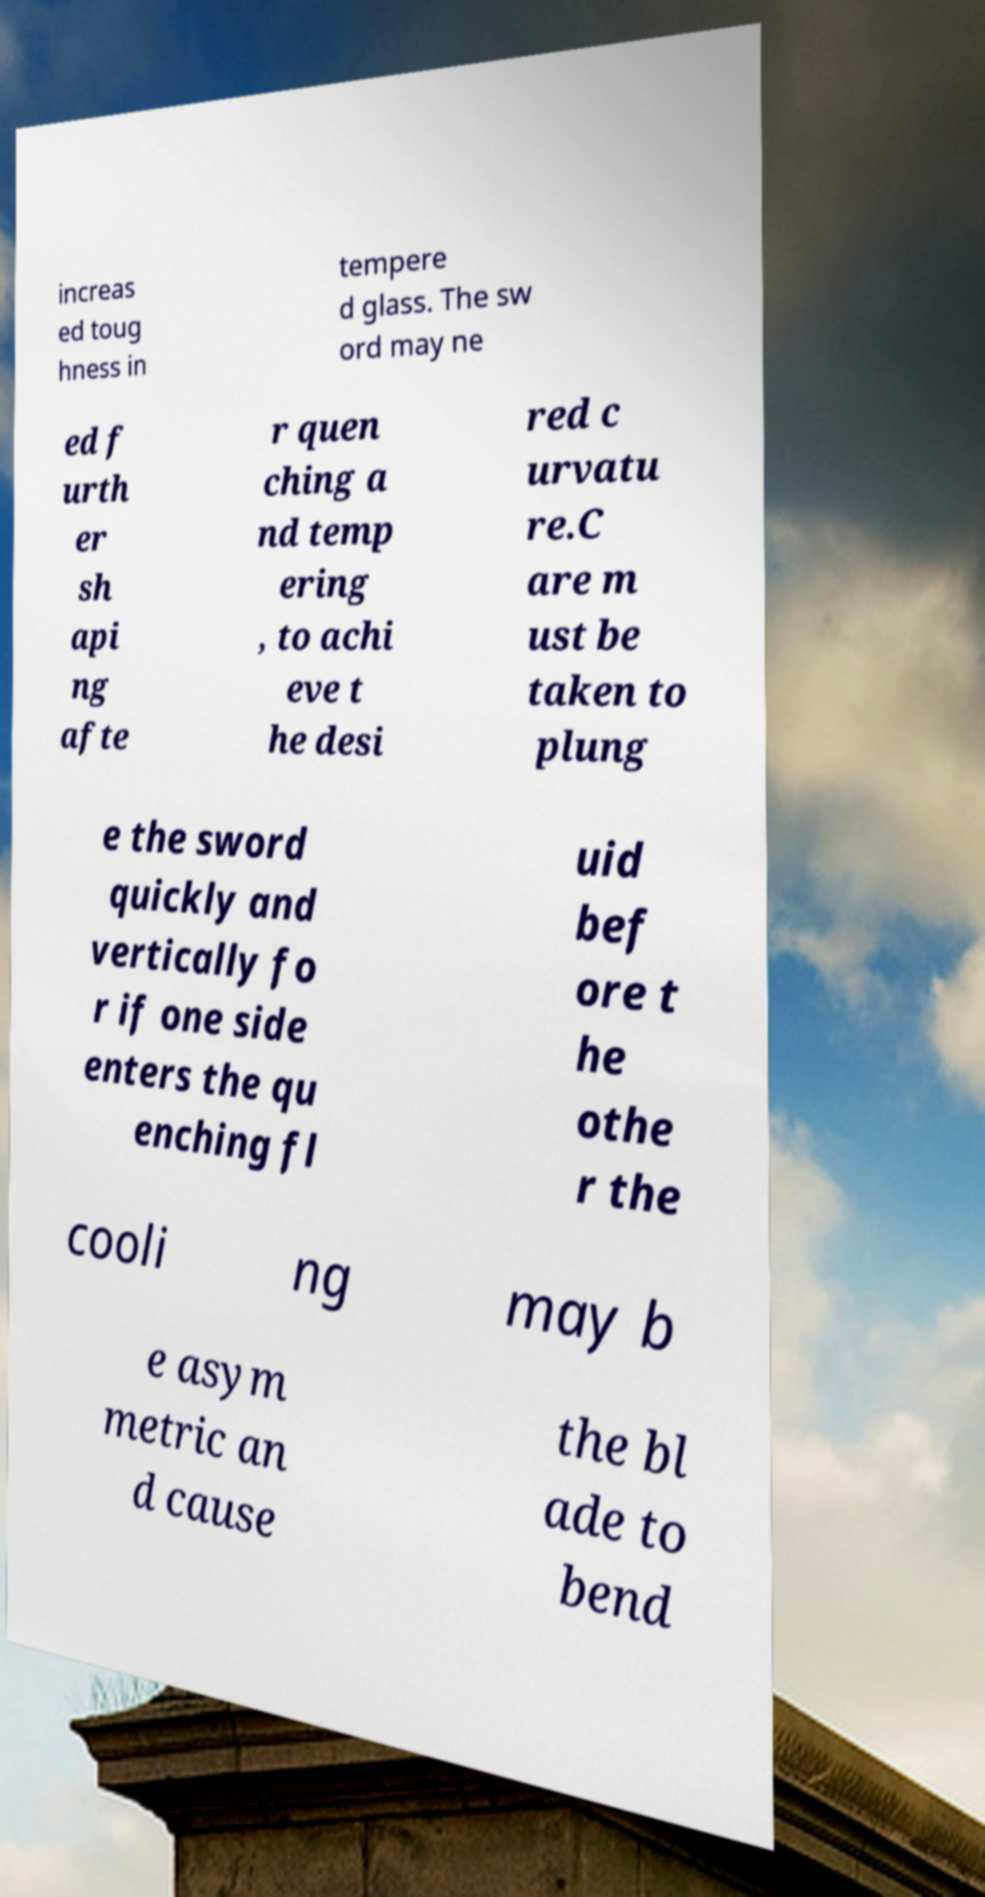There's text embedded in this image that I need extracted. Can you transcribe it verbatim? increas ed toug hness in tempere d glass. The sw ord may ne ed f urth er sh api ng afte r quen ching a nd temp ering , to achi eve t he desi red c urvatu re.C are m ust be taken to plung e the sword quickly and vertically fo r if one side enters the qu enching fl uid bef ore t he othe r the cooli ng may b e asym metric an d cause the bl ade to bend 